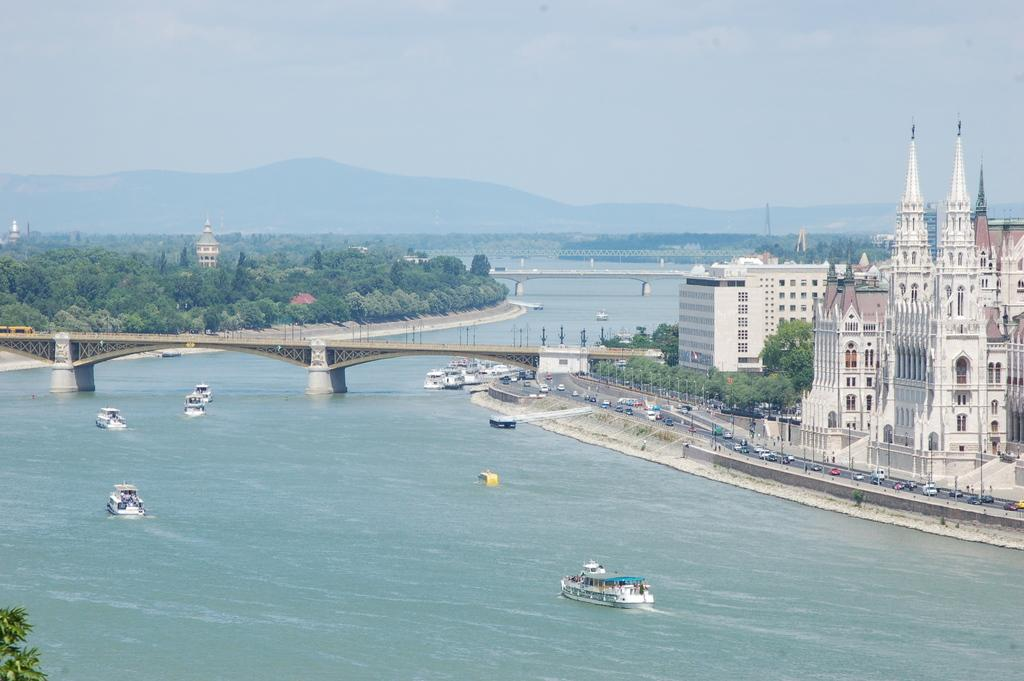What is on the water in the image? There are boats on the water in the image. What structure is above the water? There is a bridge above the water in the image. What type of structures can be seen in the image? There are buildings in the image. What type of transportation is visible in the image? There are vehicles in the image. What can be seen in the background of the image? Trees and mountains are visible in the background of the image. What type of sand can be seen on the bridge in the image? There is no sand present on the bridge in the image. What toy is being played with by the trees in the background? There are no toys present in the image, and the trees are not playing with anything. 